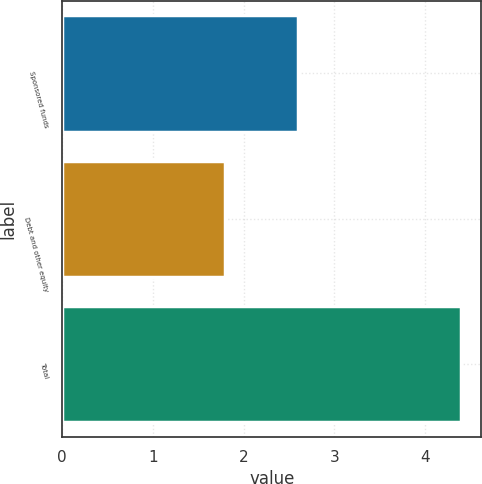Convert chart. <chart><loc_0><loc_0><loc_500><loc_500><bar_chart><fcel>Sponsored funds<fcel>Debt and other equity<fcel>Total<nl><fcel>2.6<fcel>1.8<fcel>4.4<nl></chart> 